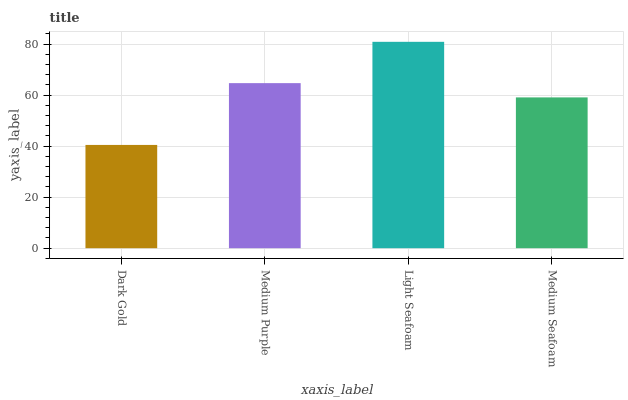Is Medium Purple the minimum?
Answer yes or no. No. Is Medium Purple the maximum?
Answer yes or no. No. Is Medium Purple greater than Dark Gold?
Answer yes or no. Yes. Is Dark Gold less than Medium Purple?
Answer yes or no. Yes. Is Dark Gold greater than Medium Purple?
Answer yes or no. No. Is Medium Purple less than Dark Gold?
Answer yes or no. No. Is Medium Purple the high median?
Answer yes or no. Yes. Is Medium Seafoam the low median?
Answer yes or no. Yes. Is Light Seafoam the high median?
Answer yes or no. No. Is Medium Purple the low median?
Answer yes or no. No. 